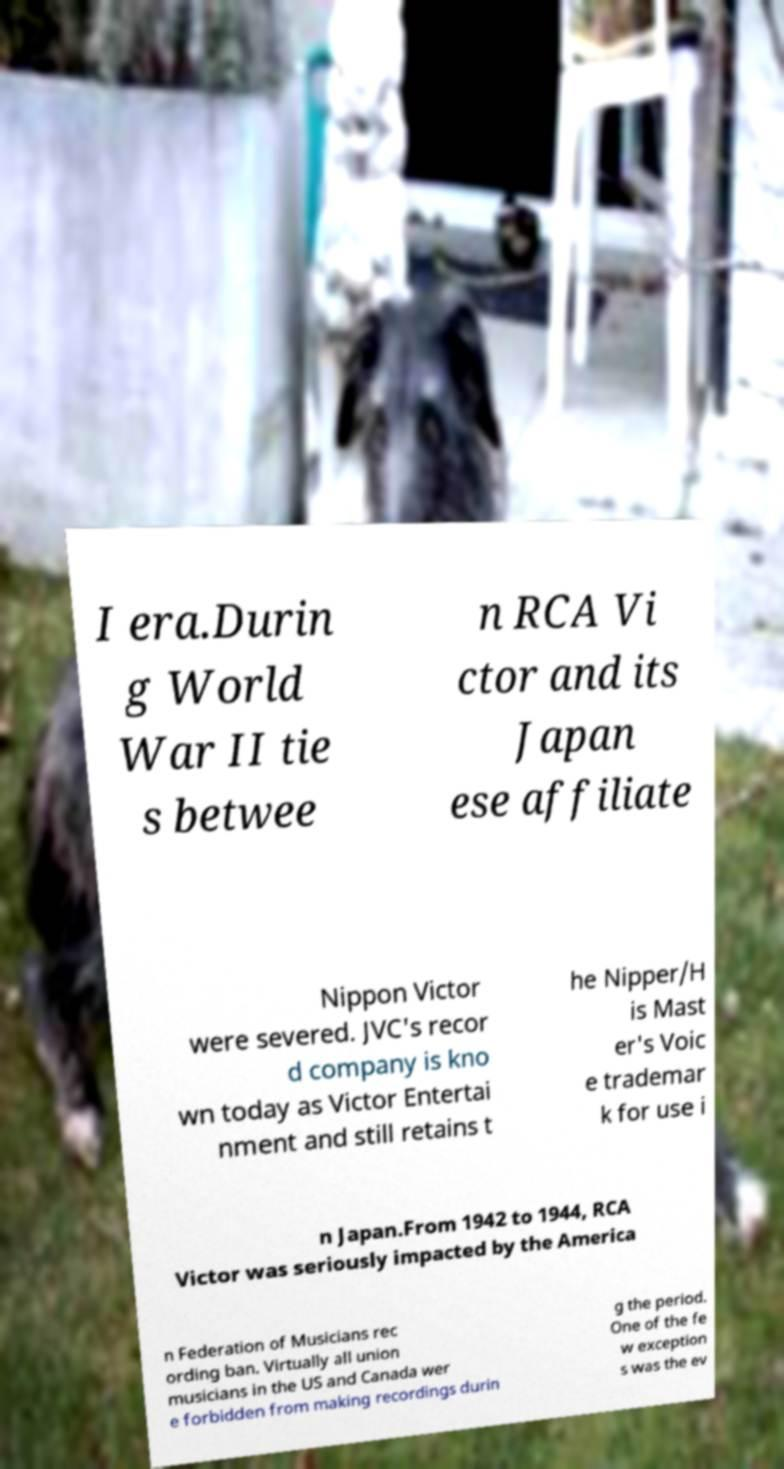There's text embedded in this image that I need extracted. Can you transcribe it verbatim? I era.Durin g World War II tie s betwee n RCA Vi ctor and its Japan ese affiliate Nippon Victor were severed. JVC's recor d company is kno wn today as Victor Entertai nment and still retains t he Nipper/H is Mast er's Voic e trademar k for use i n Japan.From 1942 to 1944, RCA Victor was seriously impacted by the America n Federation of Musicians rec ording ban. Virtually all union musicians in the US and Canada wer e forbidden from making recordings durin g the period. One of the fe w exception s was the ev 